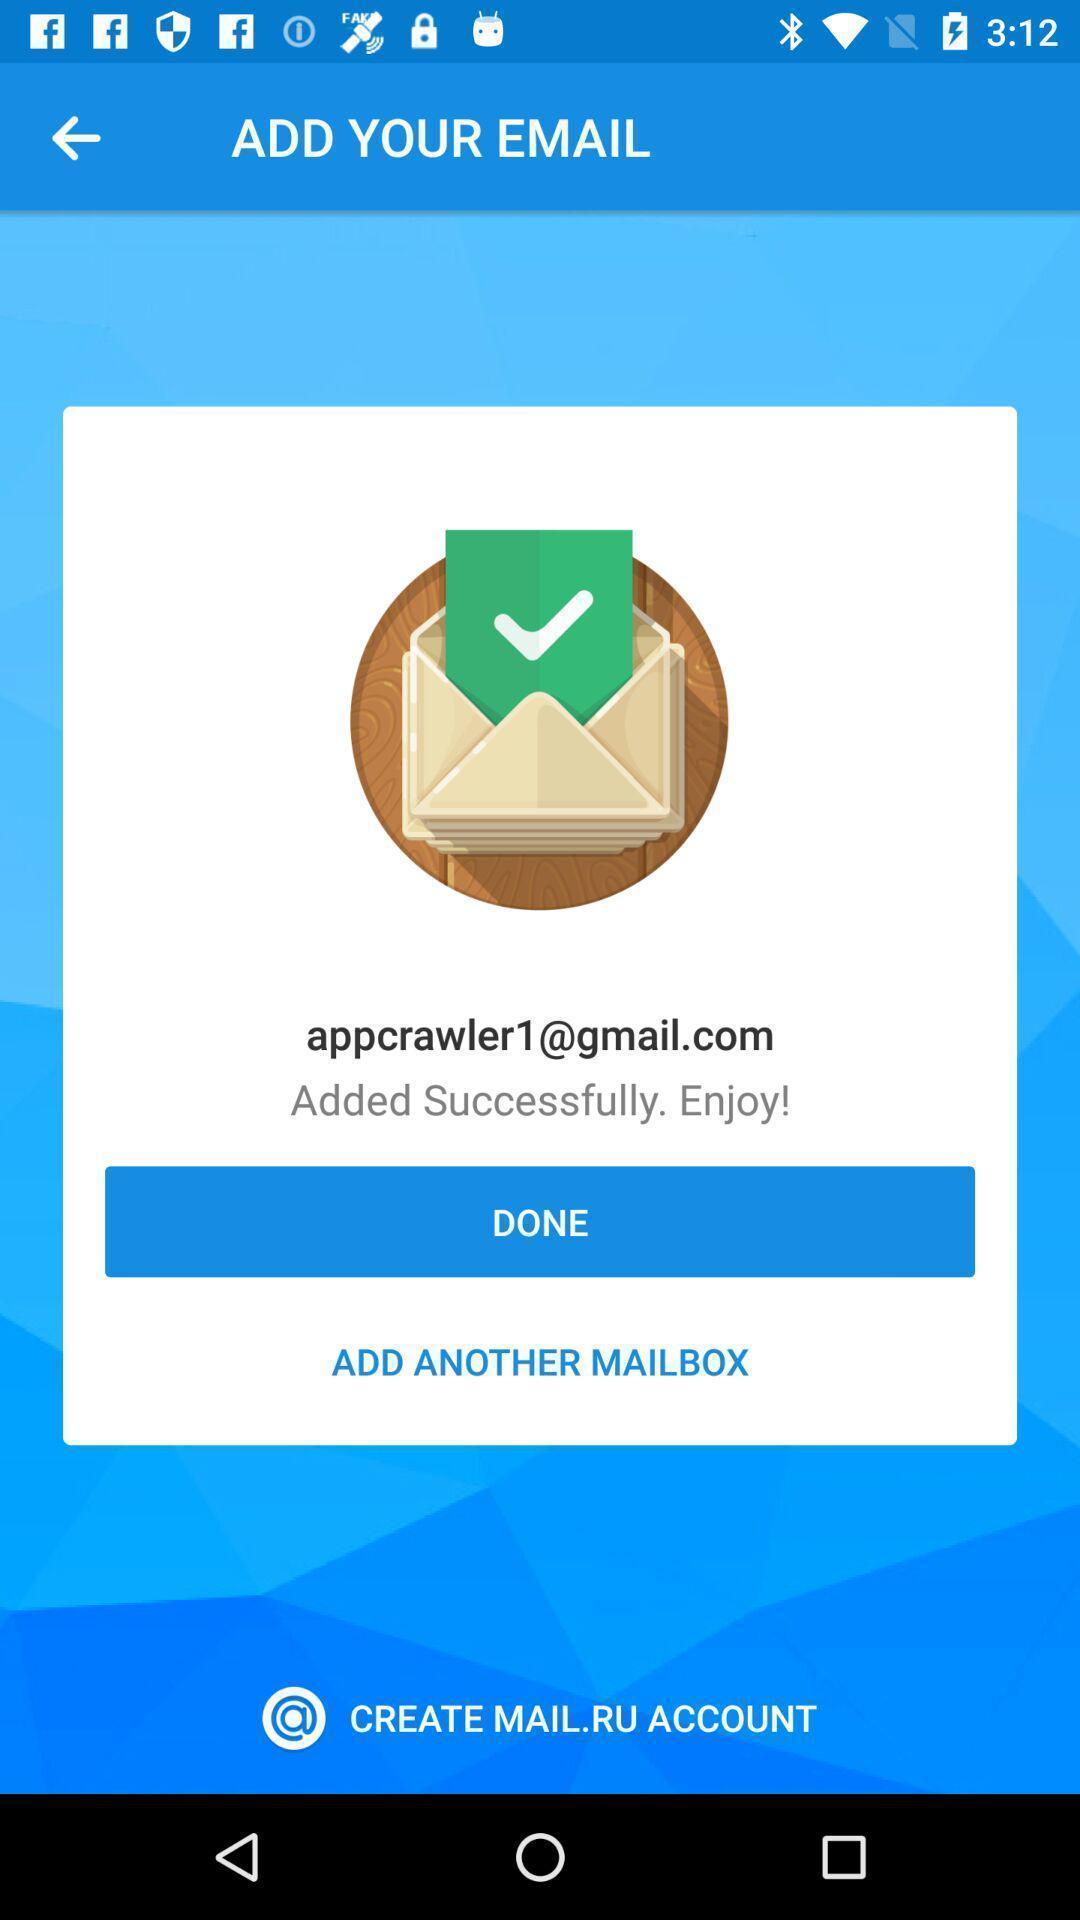Describe the key features of this screenshot. Screen shows to add an email. 